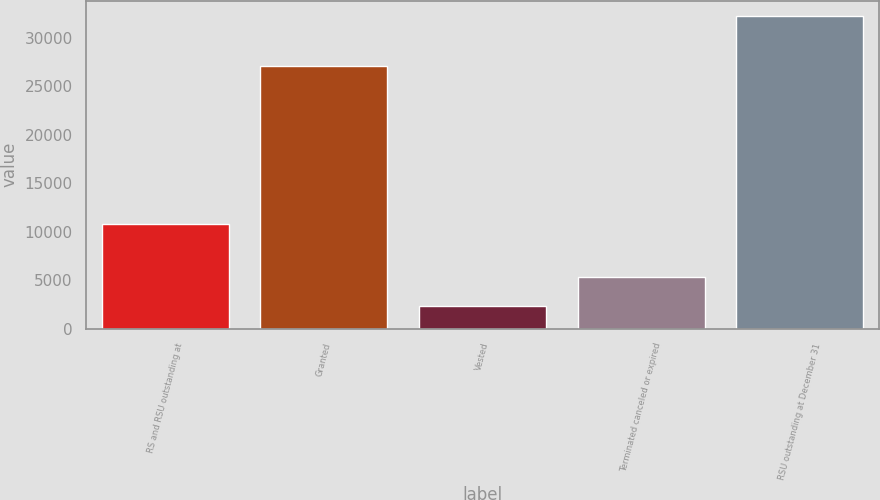<chart> <loc_0><loc_0><loc_500><loc_500><bar_chart><fcel>RS and RSU outstanding at<fcel>Granted<fcel>Vested<fcel>Terminated canceled or expired<fcel>RSU outstanding at December 31<nl><fcel>10755<fcel>27102<fcel>2308<fcel>5300.2<fcel>32230<nl></chart> 